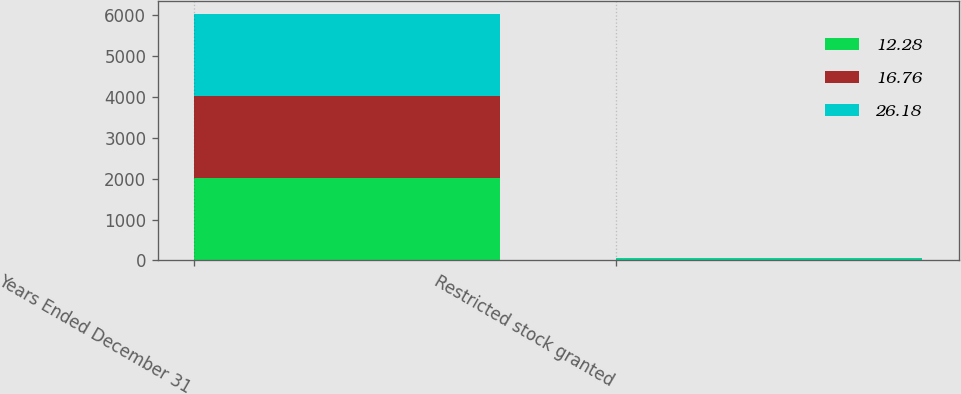<chart> <loc_0><loc_0><loc_500><loc_500><stacked_bar_chart><ecel><fcel>Years Ended December 31<fcel>Restricted stock granted<nl><fcel>12.28<fcel>2014<fcel>26.15<nl><fcel>16.76<fcel>2013<fcel>16.65<nl><fcel>26.18<fcel>2012<fcel>12.32<nl></chart> 